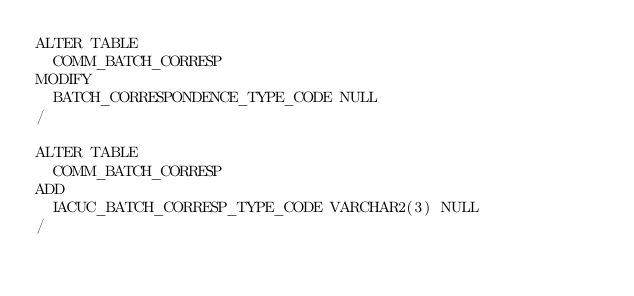Convert code to text. <code><loc_0><loc_0><loc_500><loc_500><_SQL_>ALTER TABLE
  COMM_BATCH_CORRESP 
MODIFY
  BATCH_CORRESPONDENCE_TYPE_CODE NULL
/

ALTER TABLE
  COMM_BATCH_CORRESP 
ADD 
  IACUC_BATCH_CORRESP_TYPE_CODE VARCHAR2(3) NULL
/
</code> 